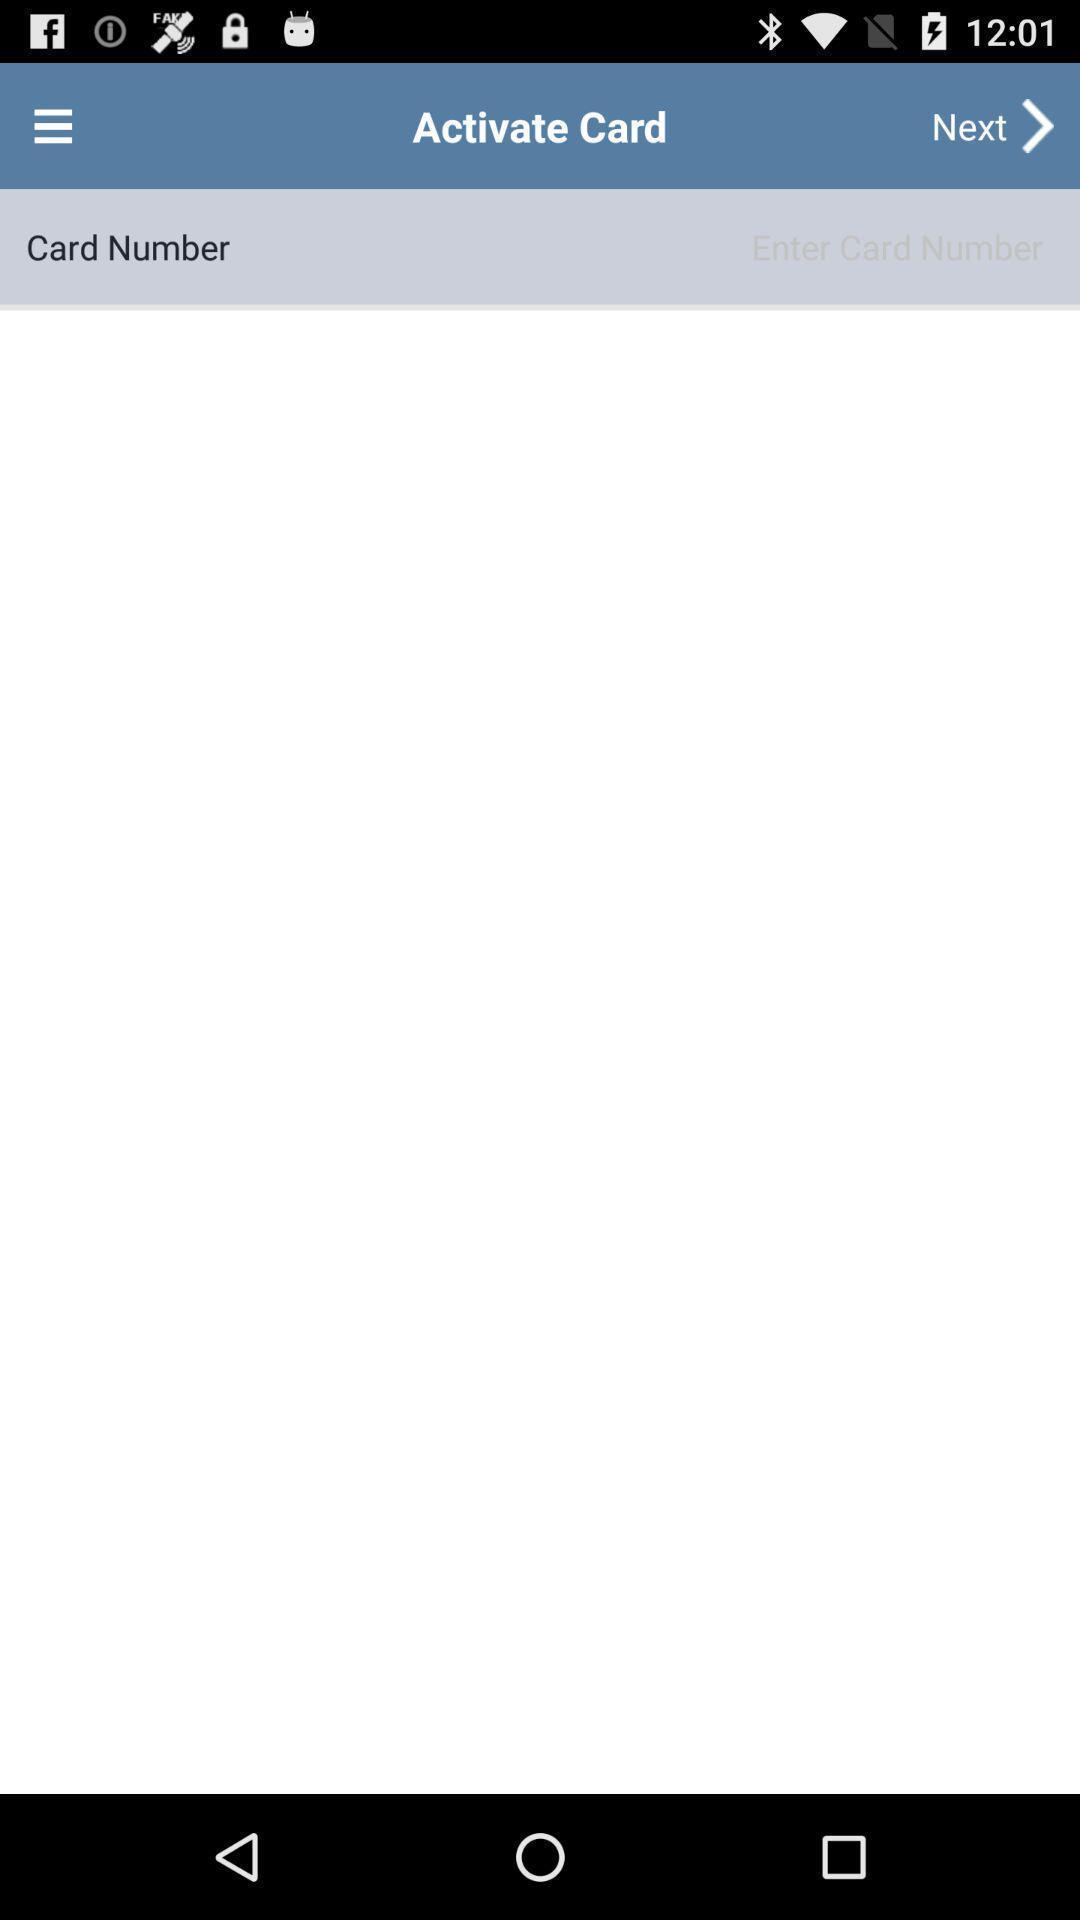Provide a description of this screenshot. Page showing list of card information. 